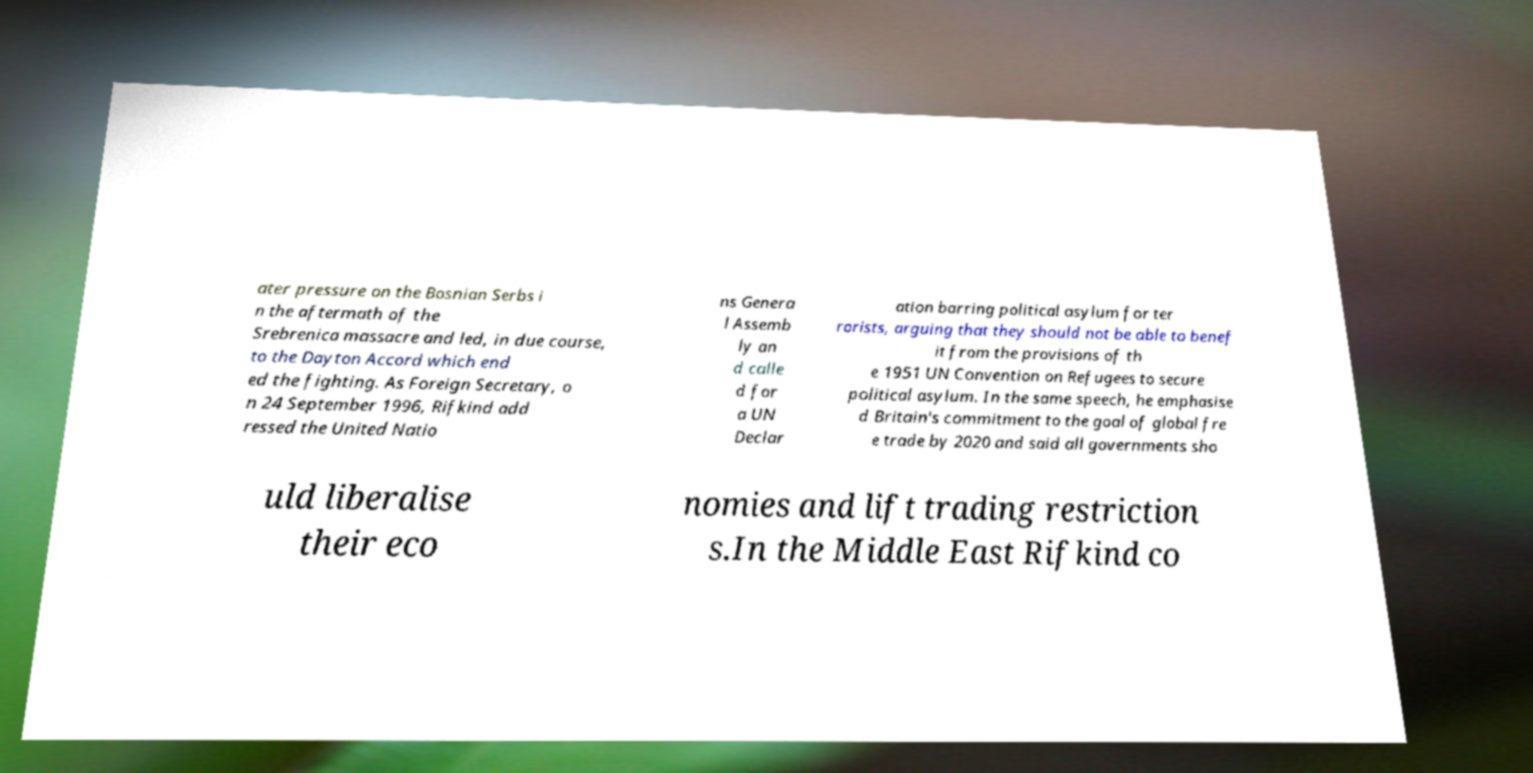Please read and relay the text visible in this image. What does it say? ater pressure on the Bosnian Serbs i n the aftermath of the Srebrenica massacre and led, in due course, to the Dayton Accord which end ed the fighting. As Foreign Secretary, o n 24 September 1996, Rifkind add ressed the United Natio ns Genera l Assemb ly an d calle d for a UN Declar ation barring political asylum for ter rorists, arguing that they should not be able to benef it from the provisions of th e 1951 UN Convention on Refugees to secure political asylum. In the same speech, he emphasise d Britain's commitment to the goal of global fre e trade by 2020 and said all governments sho uld liberalise their eco nomies and lift trading restriction s.In the Middle East Rifkind co 